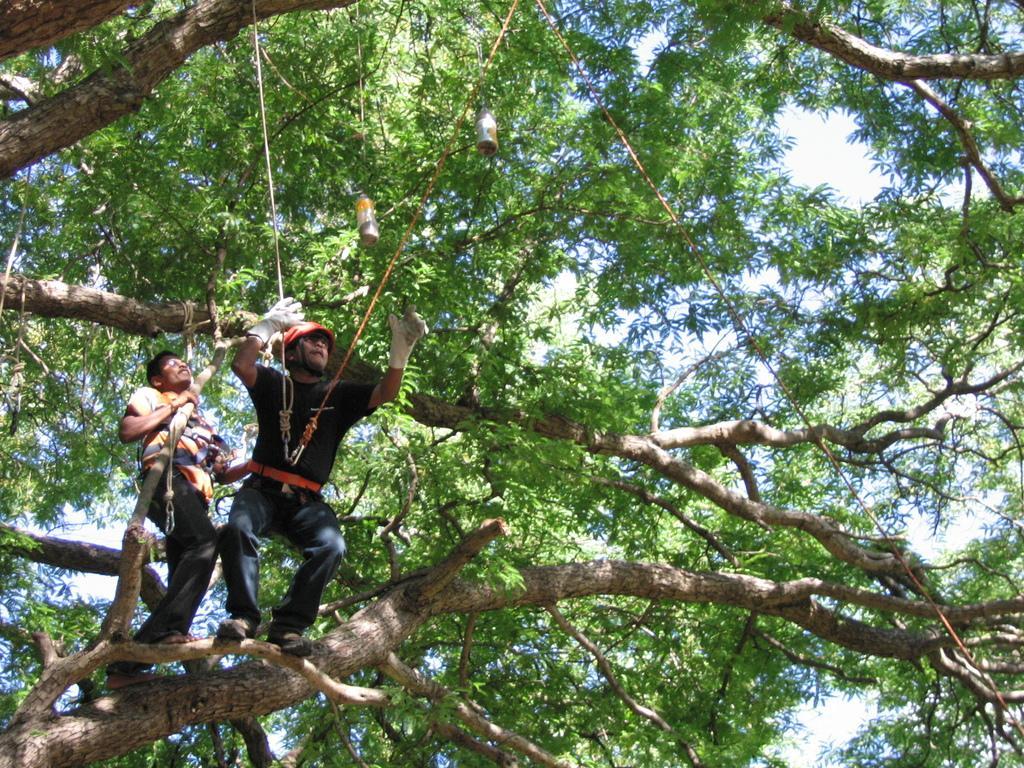Could you give a brief overview of what you see in this image? in this image we can see persons standing on the branch of a tree and holding robes. In the background we can see trees, bird feeders and sky. 